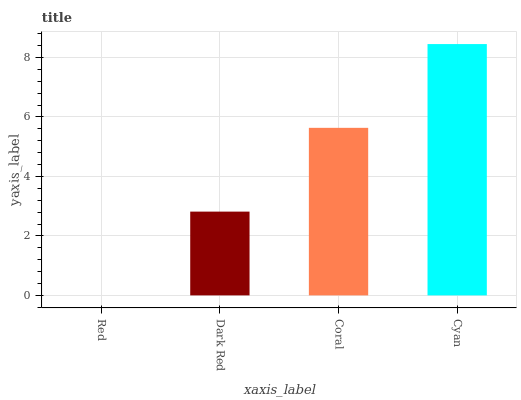Is Red the minimum?
Answer yes or no. Yes. Is Cyan the maximum?
Answer yes or no. Yes. Is Dark Red the minimum?
Answer yes or no. No. Is Dark Red the maximum?
Answer yes or no. No. Is Dark Red greater than Red?
Answer yes or no. Yes. Is Red less than Dark Red?
Answer yes or no. Yes. Is Red greater than Dark Red?
Answer yes or no. No. Is Dark Red less than Red?
Answer yes or no. No. Is Coral the high median?
Answer yes or no. Yes. Is Dark Red the low median?
Answer yes or no. Yes. Is Dark Red the high median?
Answer yes or no. No. Is Red the low median?
Answer yes or no. No. 